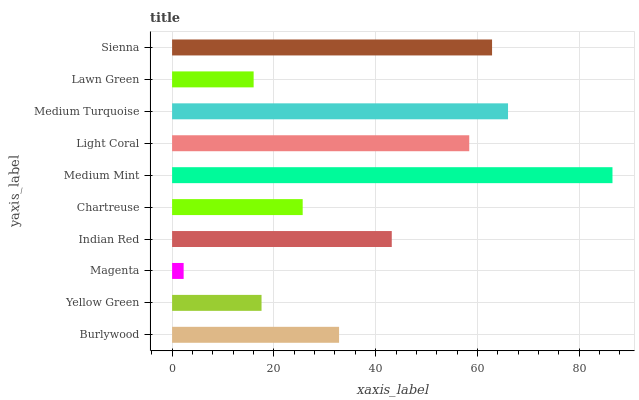Is Magenta the minimum?
Answer yes or no. Yes. Is Medium Mint the maximum?
Answer yes or no. Yes. Is Yellow Green the minimum?
Answer yes or no. No. Is Yellow Green the maximum?
Answer yes or no. No. Is Burlywood greater than Yellow Green?
Answer yes or no. Yes. Is Yellow Green less than Burlywood?
Answer yes or no. Yes. Is Yellow Green greater than Burlywood?
Answer yes or no. No. Is Burlywood less than Yellow Green?
Answer yes or no. No. Is Indian Red the high median?
Answer yes or no. Yes. Is Burlywood the low median?
Answer yes or no. Yes. Is Light Coral the high median?
Answer yes or no. No. Is Medium Mint the low median?
Answer yes or no. No. 